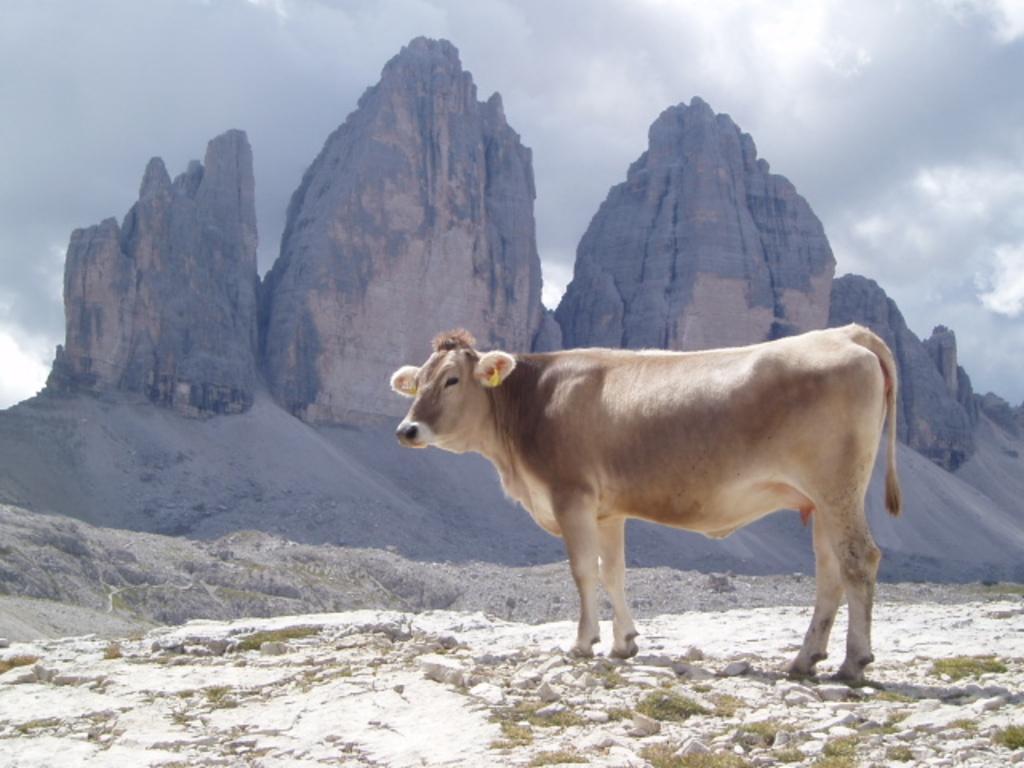Could you give a brief overview of what you see in this image? In the foreground of the picture there are stones, rock and a cow. In the background there are mountains and sand. Sky is cloudy. In the center of the picture there are shrubs and soil. 